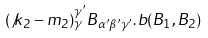<formula> <loc_0><loc_0><loc_500><loc_500>( \not k _ { 2 } - m _ { 2 } ) _ { \gamma } ^ { \gamma ^ { \prime } } B _ { \alpha ^ { \prime } \beta ^ { \prime } \gamma ^ { \prime } } . b ( B _ { 1 } , B _ { 2 } )</formula> 